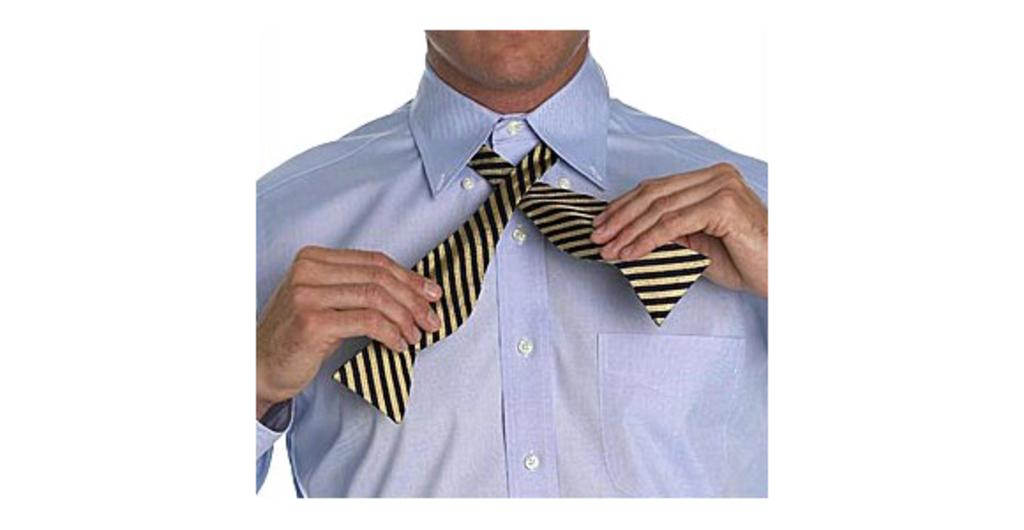What is present in the image? There is a person in the image. Can you describe what the person is wearing? The person is wearing a shirt. What is the person holding in their hands? The person is holding a tie with their hands. What type of breakfast is the person eating in the image? There is no indication of any breakfast in the image. How many lizards can be seen in the image? There are no lizards present in the image. What is the gender of the person in the image? The provided facts do not specify the gender of the person; we only know that they are holding a tie. 